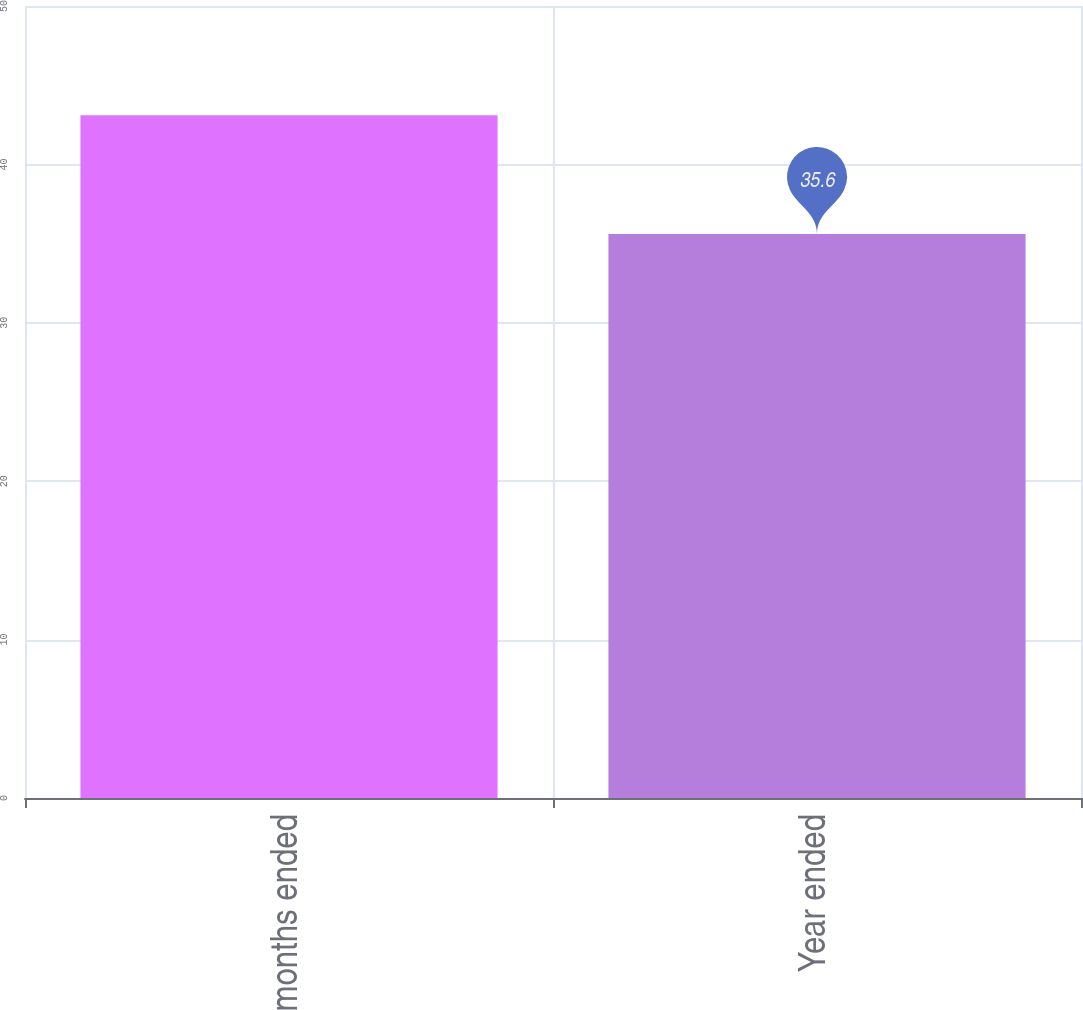Convert chart to OTSL. <chart><loc_0><loc_0><loc_500><loc_500><bar_chart><fcel>Three months ended<fcel>Year ended<nl><fcel>43.1<fcel>35.6<nl></chart> 